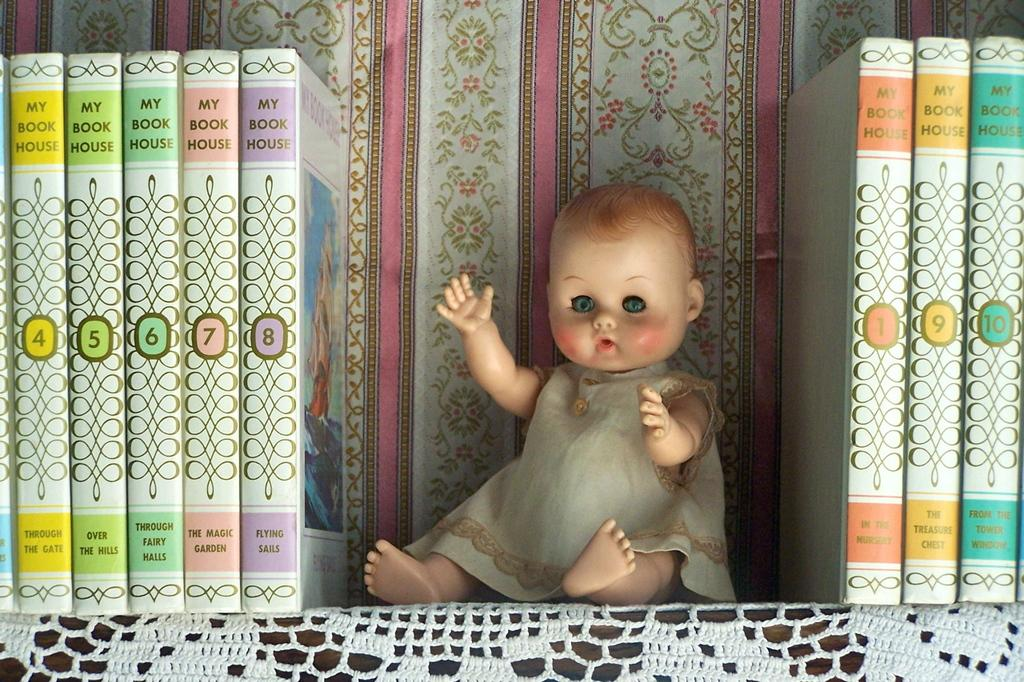<image>
Offer a succinct explanation of the picture presented. A row of My Book House editions books with the numbers 4-10 on the books and a doll in the middle 